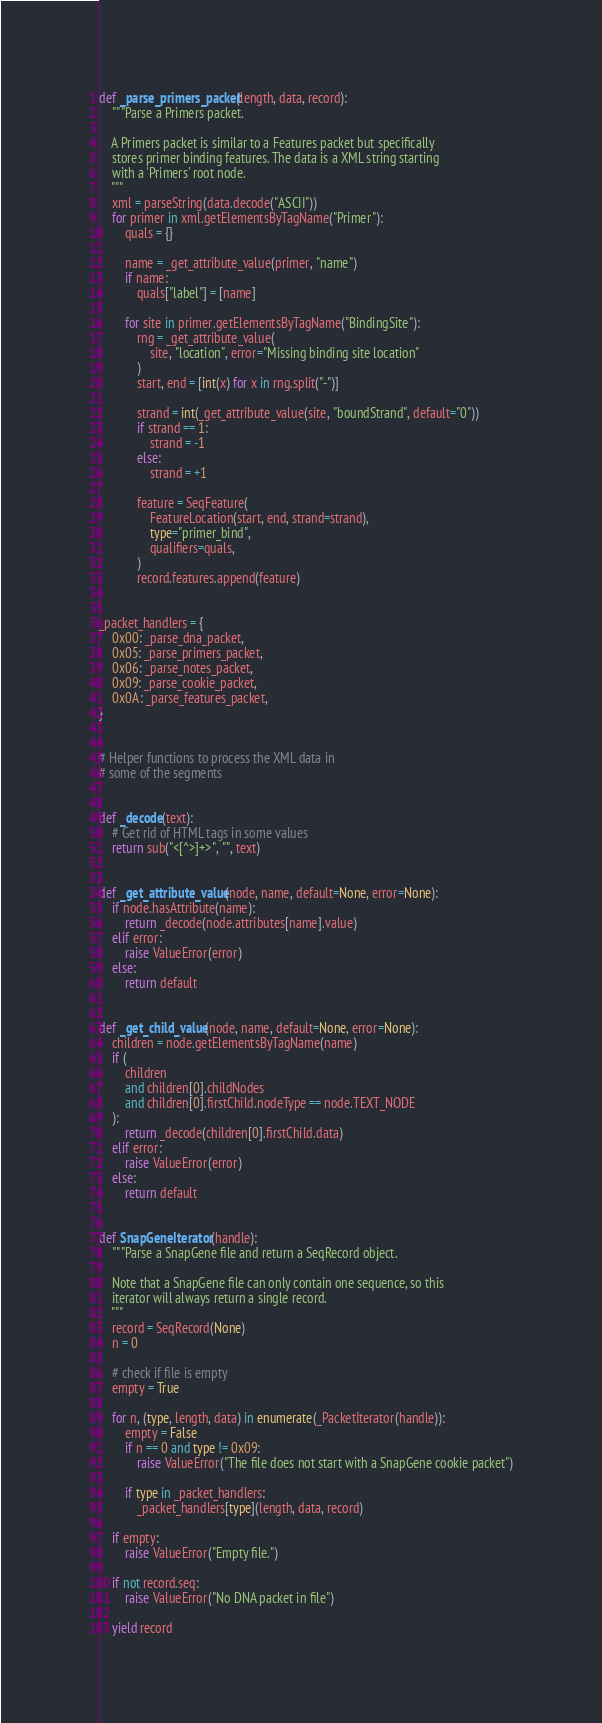Convert code to text. <code><loc_0><loc_0><loc_500><loc_500><_Python_>

def _parse_primers_packet(length, data, record):
    """Parse a Primers packet.

    A Primers packet is similar to a Features packet but specifically
    stores primer binding features. The data is a XML string starting
    with a 'Primers' root node.
    """
    xml = parseString(data.decode("ASCII"))
    for primer in xml.getElementsByTagName("Primer"):
        quals = {}

        name = _get_attribute_value(primer, "name")
        if name:
            quals["label"] = [name]

        for site in primer.getElementsByTagName("BindingSite"):
            rng = _get_attribute_value(
                site, "location", error="Missing binding site location"
            )
            start, end = [int(x) for x in rng.split("-")]

            strand = int(_get_attribute_value(site, "boundStrand", default="0"))
            if strand == 1:
                strand = -1
            else:
                strand = +1

            feature = SeqFeature(
                FeatureLocation(start, end, strand=strand),
                type="primer_bind",
                qualifiers=quals,
            )
            record.features.append(feature)


_packet_handlers = {
    0x00: _parse_dna_packet,
    0x05: _parse_primers_packet,
    0x06: _parse_notes_packet,
    0x09: _parse_cookie_packet,
    0x0A: _parse_features_packet,
}


# Helper functions to process the XML data in
# some of the segments


def _decode(text):
    # Get rid of HTML tags in some values
    return sub("<[^>]+>", "", text)


def _get_attribute_value(node, name, default=None, error=None):
    if node.hasAttribute(name):
        return _decode(node.attributes[name].value)
    elif error:
        raise ValueError(error)
    else:
        return default


def _get_child_value(node, name, default=None, error=None):
    children = node.getElementsByTagName(name)
    if (
        children
        and children[0].childNodes
        and children[0].firstChild.nodeType == node.TEXT_NODE
    ):
        return _decode(children[0].firstChild.data)
    elif error:
        raise ValueError(error)
    else:
        return default


def SnapGeneIterator(handle):
    """Parse a SnapGene file and return a SeqRecord object.

    Note that a SnapGene file can only contain one sequence, so this
    iterator will always return a single record.
    """
    record = SeqRecord(None)
    n = 0

    # check if file is empty
    empty = True

    for n, (type, length, data) in enumerate(_PacketIterator(handle)):
        empty = False
        if n == 0 and type != 0x09:
            raise ValueError("The file does not start with a SnapGene cookie packet")

        if type in _packet_handlers:
            _packet_handlers[type](length, data, record)

    if empty:
        raise ValueError("Empty file.")

    if not record.seq:
        raise ValueError("No DNA packet in file")

    yield record
</code> 